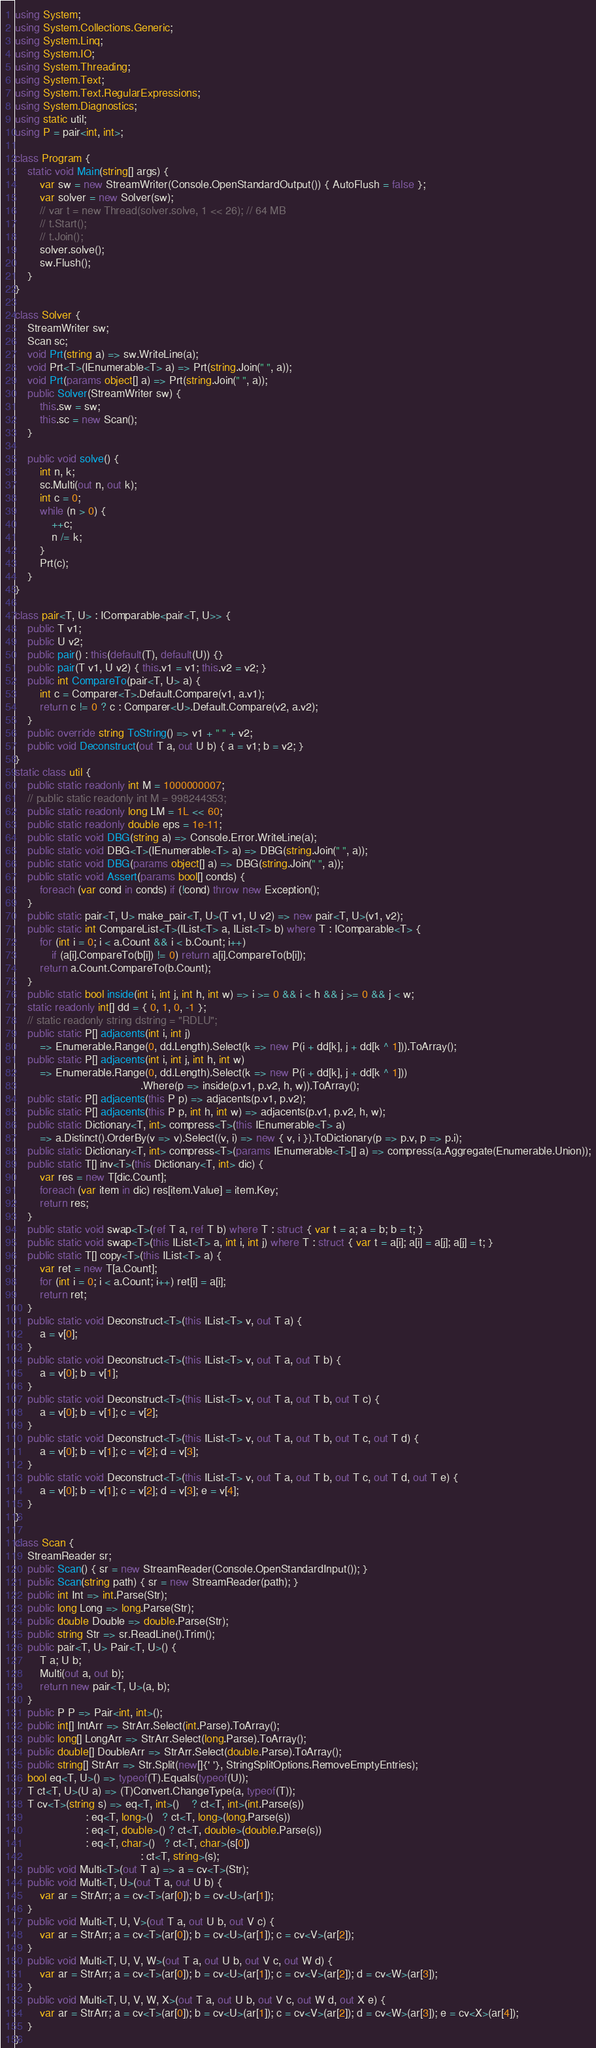Convert code to text. <code><loc_0><loc_0><loc_500><loc_500><_C#_>using System;
using System.Collections.Generic;
using System.Linq;
using System.IO;
using System.Threading;
using System.Text;
using System.Text.RegularExpressions;
using System.Diagnostics;
using static util;
using P = pair<int, int>;

class Program {
    static void Main(string[] args) {
        var sw = new StreamWriter(Console.OpenStandardOutput()) { AutoFlush = false };
        var solver = new Solver(sw);
        // var t = new Thread(solver.solve, 1 << 26); // 64 MB
        // t.Start();
        // t.Join();
        solver.solve();
        sw.Flush();
    }
}

class Solver {
    StreamWriter sw;
    Scan sc;
    void Prt(string a) => sw.WriteLine(a);
    void Prt<T>(IEnumerable<T> a) => Prt(string.Join(" ", a));
    void Prt(params object[] a) => Prt(string.Join(" ", a));
    public Solver(StreamWriter sw) {
        this.sw = sw;
        this.sc = new Scan();
    }

    public void solve() {
        int n, k;
        sc.Multi(out n, out k);
        int c = 0;
        while (n > 0) {
            ++c;
            n /= k;
        }
        Prt(c);
    }
}

class pair<T, U> : IComparable<pair<T, U>> {
    public T v1;
    public U v2;
    public pair() : this(default(T), default(U)) {}
    public pair(T v1, U v2) { this.v1 = v1; this.v2 = v2; }
    public int CompareTo(pair<T, U> a) {
        int c = Comparer<T>.Default.Compare(v1, a.v1);
        return c != 0 ? c : Comparer<U>.Default.Compare(v2, a.v2);
    }
    public override string ToString() => v1 + " " + v2;
    public void Deconstruct(out T a, out U b) { a = v1; b = v2; }
}
static class util {
    public static readonly int M = 1000000007;
    // public static readonly int M = 998244353;
    public static readonly long LM = 1L << 60;
    public static readonly double eps = 1e-11;
    public static void DBG(string a) => Console.Error.WriteLine(a);
    public static void DBG<T>(IEnumerable<T> a) => DBG(string.Join(" ", a));
    public static void DBG(params object[] a) => DBG(string.Join(" ", a));
    public static void Assert(params bool[] conds) {
        foreach (var cond in conds) if (!cond) throw new Exception();
    }
    public static pair<T, U> make_pair<T, U>(T v1, U v2) => new pair<T, U>(v1, v2);
    public static int CompareList<T>(IList<T> a, IList<T> b) where T : IComparable<T> {
        for (int i = 0; i < a.Count && i < b.Count; i++)
            if (a[i].CompareTo(b[i]) != 0) return a[i].CompareTo(b[i]);
        return a.Count.CompareTo(b.Count);
    }
    public static bool inside(int i, int j, int h, int w) => i >= 0 && i < h && j >= 0 && j < w;
    static readonly int[] dd = { 0, 1, 0, -1 };
    // static readonly string dstring = "RDLU";
    public static P[] adjacents(int i, int j)
        => Enumerable.Range(0, dd.Length).Select(k => new P(i + dd[k], j + dd[k ^ 1])).ToArray();
    public static P[] adjacents(int i, int j, int h, int w)
        => Enumerable.Range(0, dd.Length).Select(k => new P(i + dd[k], j + dd[k ^ 1]))
                                         .Where(p => inside(p.v1, p.v2, h, w)).ToArray();
    public static P[] adjacents(this P p) => adjacents(p.v1, p.v2);
    public static P[] adjacents(this P p, int h, int w) => adjacents(p.v1, p.v2, h, w);
    public static Dictionary<T, int> compress<T>(this IEnumerable<T> a)
        => a.Distinct().OrderBy(v => v).Select((v, i) => new { v, i }).ToDictionary(p => p.v, p => p.i);
    public static Dictionary<T, int> compress<T>(params IEnumerable<T>[] a) => compress(a.Aggregate(Enumerable.Union));
    public static T[] inv<T>(this Dictionary<T, int> dic) {
        var res = new T[dic.Count];
        foreach (var item in dic) res[item.Value] = item.Key;
        return res;
    }
    public static void swap<T>(ref T a, ref T b) where T : struct { var t = a; a = b; b = t; }
    public static void swap<T>(this IList<T> a, int i, int j) where T : struct { var t = a[i]; a[i] = a[j]; a[j] = t; }
    public static T[] copy<T>(this IList<T> a) {
        var ret = new T[a.Count];
        for (int i = 0; i < a.Count; i++) ret[i] = a[i];
        return ret;
    }
    public static void Deconstruct<T>(this IList<T> v, out T a) {
        a = v[0];
    }
    public static void Deconstruct<T>(this IList<T> v, out T a, out T b) {
        a = v[0]; b = v[1];
    }
    public static void Deconstruct<T>(this IList<T> v, out T a, out T b, out T c) {
        a = v[0]; b = v[1]; c = v[2];
    }
    public static void Deconstruct<T>(this IList<T> v, out T a, out T b, out T c, out T d) {
        a = v[0]; b = v[1]; c = v[2]; d = v[3];
    }
    public static void Deconstruct<T>(this IList<T> v, out T a, out T b, out T c, out T d, out T e) {
        a = v[0]; b = v[1]; c = v[2]; d = v[3]; e = v[4];
    }
}

class Scan {
    StreamReader sr;
    public Scan() { sr = new StreamReader(Console.OpenStandardInput()); }
    public Scan(string path) { sr = new StreamReader(path); }
    public int Int => int.Parse(Str);
    public long Long => long.Parse(Str);
    public double Double => double.Parse(Str);
    public string Str => sr.ReadLine().Trim();
    public pair<T, U> Pair<T, U>() {
        T a; U b;
        Multi(out a, out b);
        return new pair<T, U>(a, b);
    }
    public P P => Pair<int, int>();
    public int[] IntArr => StrArr.Select(int.Parse).ToArray();
    public long[] LongArr => StrArr.Select(long.Parse).ToArray();
    public double[] DoubleArr => StrArr.Select(double.Parse).ToArray();
    public string[] StrArr => Str.Split(new[]{' '}, StringSplitOptions.RemoveEmptyEntries);
    bool eq<T, U>() => typeof(T).Equals(typeof(U));
    T ct<T, U>(U a) => (T)Convert.ChangeType(a, typeof(T));
    T cv<T>(string s) => eq<T, int>()    ? ct<T, int>(int.Parse(s))
                       : eq<T, long>()   ? ct<T, long>(long.Parse(s))
                       : eq<T, double>() ? ct<T, double>(double.Parse(s))
                       : eq<T, char>()   ? ct<T, char>(s[0])
                                         : ct<T, string>(s);
    public void Multi<T>(out T a) => a = cv<T>(Str);
    public void Multi<T, U>(out T a, out U b) {
        var ar = StrArr; a = cv<T>(ar[0]); b = cv<U>(ar[1]);
    }
    public void Multi<T, U, V>(out T a, out U b, out V c) {
        var ar = StrArr; a = cv<T>(ar[0]); b = cv<U>(ar[1]); c = cv<V>(ar[2]);
    }
    public void Multi<T, U, V, W>(out T a, out U b, out V c, out W d) {
        var ar = StrArr; a = cv<T>(ar[0]); b = cv<U>(ar[1]); c = cv<V>(ar[2]); d = cv<W>(ar[3]);
    }
    public void Multi<T, U, V, W, X>(out T a, out U b, out V c, out W d, out X e) {
        var ar = StrArr; a = cv<T>(ar[0]); b = cv<U>(ar[1]); c = cv<V>(ar[2]); d = cv<W>(ar[3]); e = cv<X>(ar[4]);
    }
}
</code> 